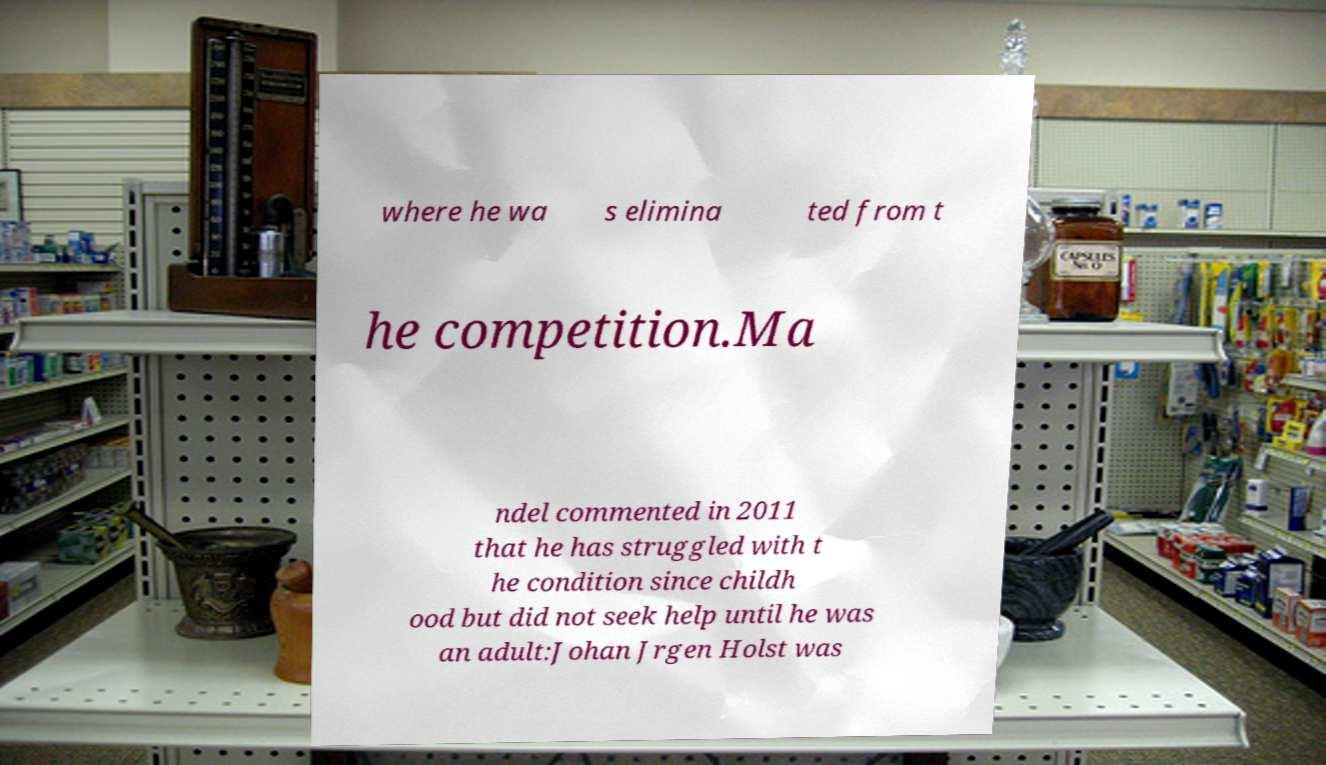Can you accurately transcribe the text from the provided image for me? where he wa s elimina ted from t he competition.Ma ndel commented in 2011 that he has struggled with t he condition since childh ood but did not seek help until he was an adult:Johan Jrgen Holst was 